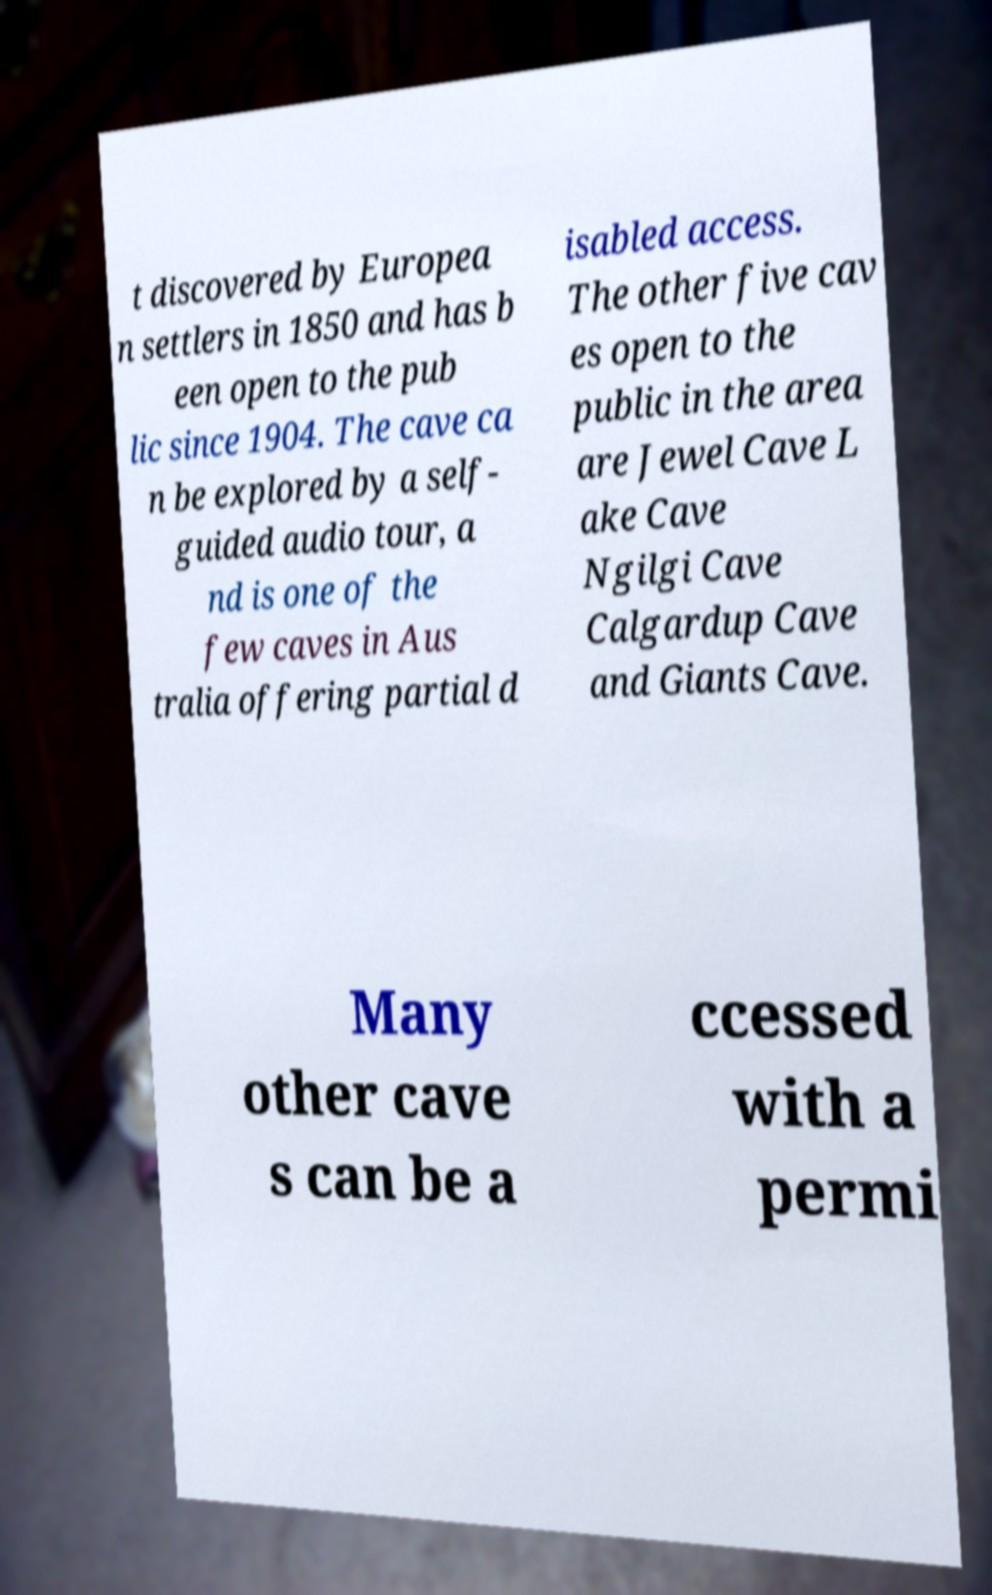Could you extract and type out the text from this image? t discovered by Europea n settlers in 1850 and has b een open to the pub lic since 1904. The cave ca n be explored by a self- guided audio tour, a nd is one of the few caves in Aus tralia offering partial d isabled access. The other five cav es open to the public in the area are Jewel Cave L ake Cave Ngilgi Cave Calgardup Cave and Giants Cave. Many other cave s can be a ccessed with a permi 